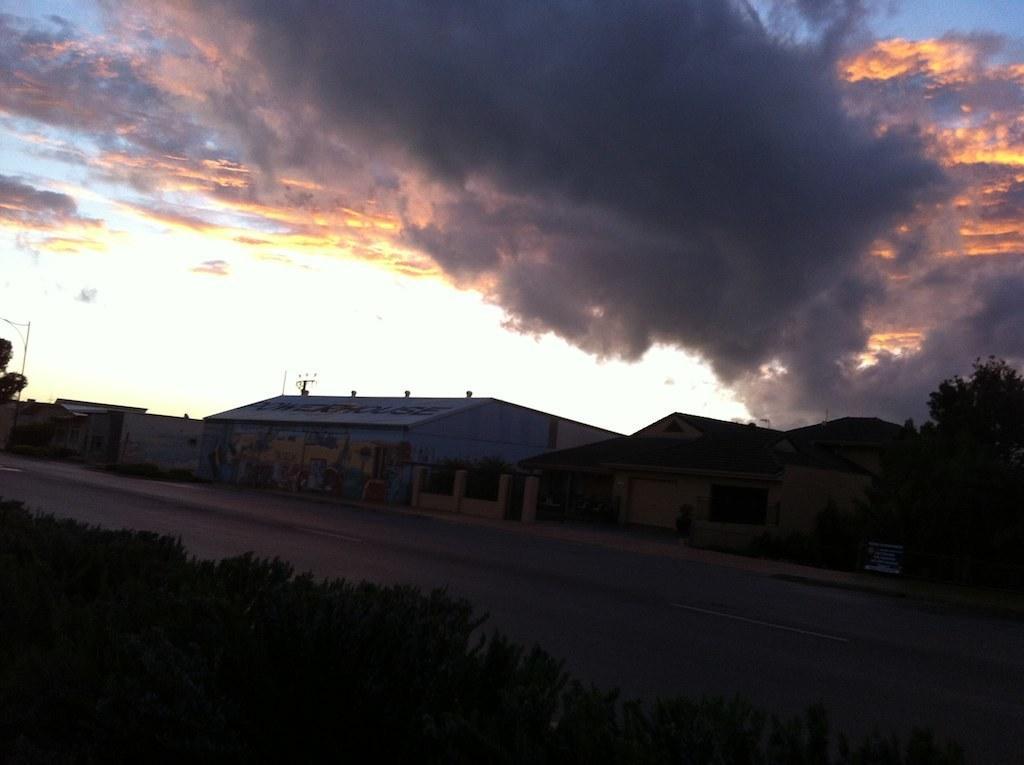In one or two sentences, can you explain what this image depicts? In this picture we can see few plants, trees, buildings and clouds, and also we can see few poles. 